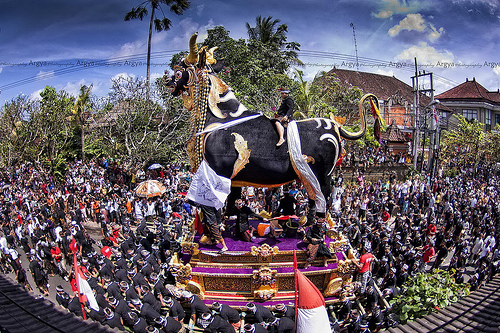<image>
Is the toy under the table? Yes. The toy is positioned underneath the table, with the table above it in the vertical space. 